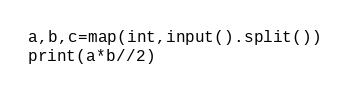<code> <loc_0><loc_0><loc_500><loc_500><_Python_>a,b,c=map(int,input().split())
print(a*b//2)</code> 